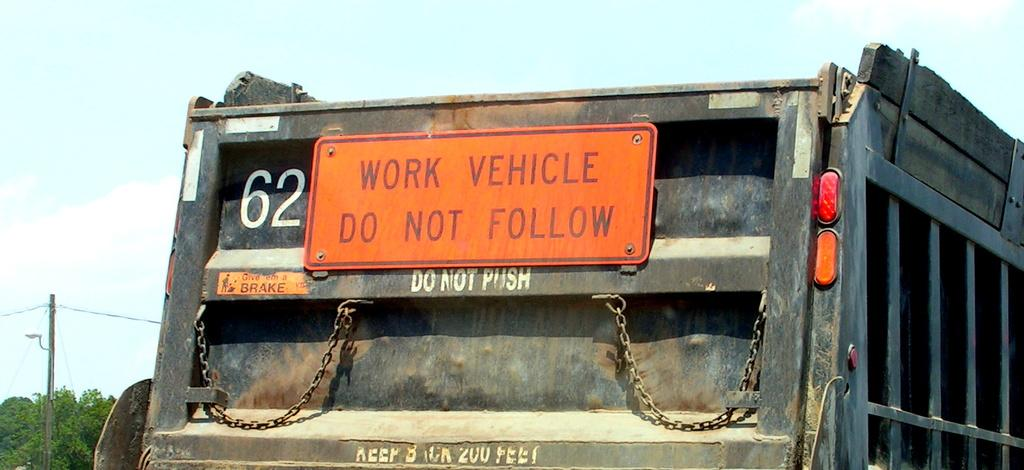What is on the road in the image? There is a vehicle on the road in the image. What else can be seen in the image besides the vehicle? There is a board, trees, a pole, wires, and the sky visible in the image. What might the board be used for? The purpose of the board is not clear from the image, but it could be used for displaying information or advertisements. How many trees are visible in the image? The number of trees visible in the image is not specified, but there are trees present. Can you hear the guitar playing in the background of the image? There is no guitar or sound present in the image, as it is a still photograph. 